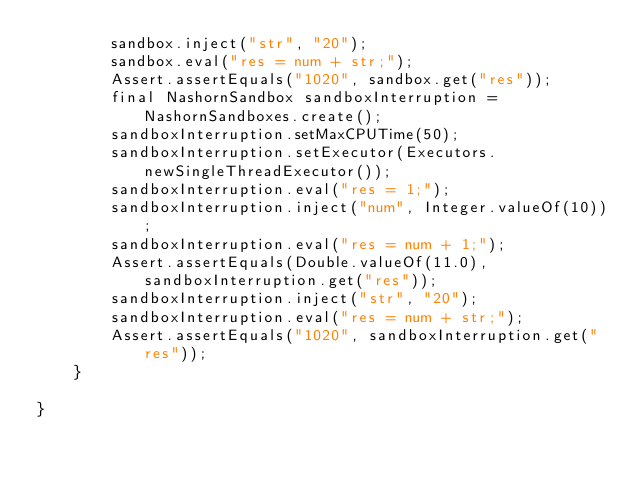Convert code to text. <code><loc_0><loc_0><loc_500><loc_500><_Java_>		sandbox.inject("str", "20");
		sandbox.eval("res = num + str;");
		Assert.assertEquals("1020", sandbox.get("res"));
		final NashornSandbox sandboxInterruption = NashornSandboxes.create();
		sandboxInterruption.setMaxCPUTime(50);
		sandboxInterruption.setExecutor(Executors.newSingleThreadExecutor());
		sandboxInterruption.eval("res = 1;");
		sandboxInterruption.inject("num", Integer.valueOf(10));
		sandboxInterruption.eval("res = num + 1;");
		Assert.assertEquals(Double.valueOf(11.0), sandboxInterruption.get("res"));
		sandboxInterruption.inject("str", "20");
		sandboxInterruption.eval("res = num + str;");
		Assert.assertEquals("1020", sandboxInterruption.get("res"));
	}

}
</code> 